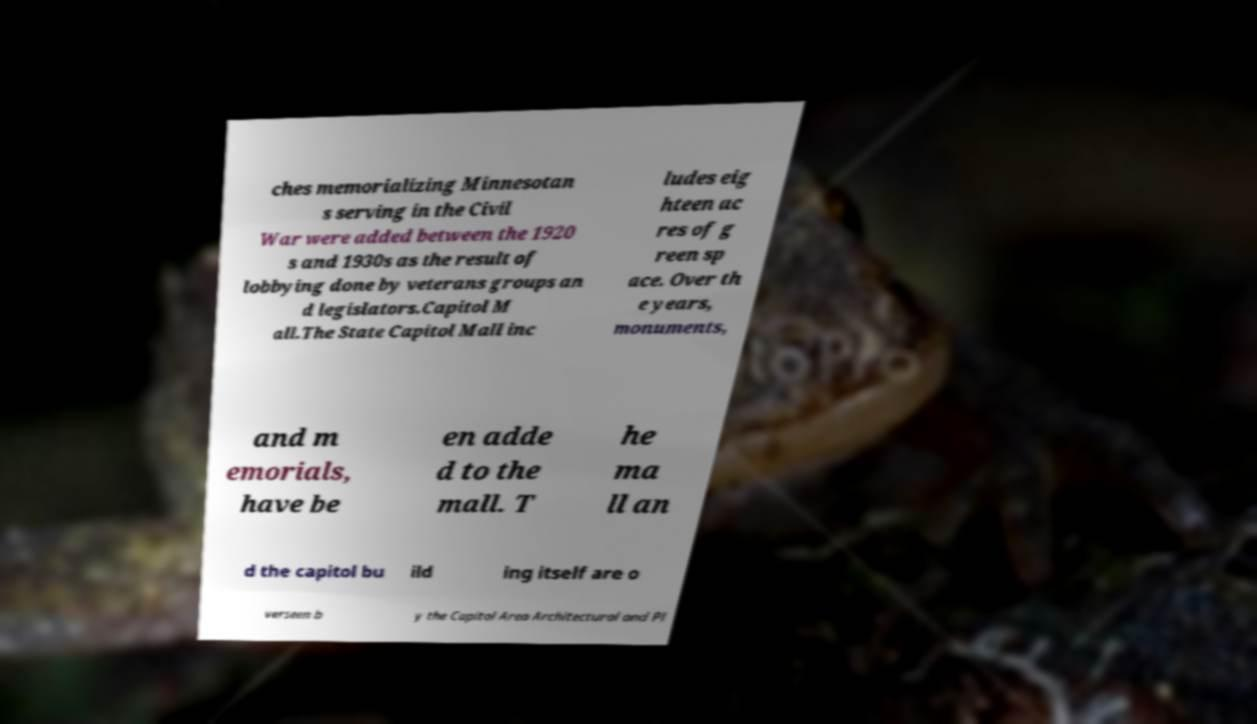I need the written content from this picture converted into text. Can you do that? ches memorializing Minnesotan s serving in the Civil War were added between the 1920 s and 1930s as the result of lobbying done by veterans groups an d legislators.Capitol M all.The State Capitol Mall inc ludes eig hteen ac res of g reen sp ace. Over th e years, monuments, and m emorials, have be en adde d to the mall. T he ma ll an d the capitol bu ild ing itself are o verseen b y the Capitol Area Architectural and Pl 